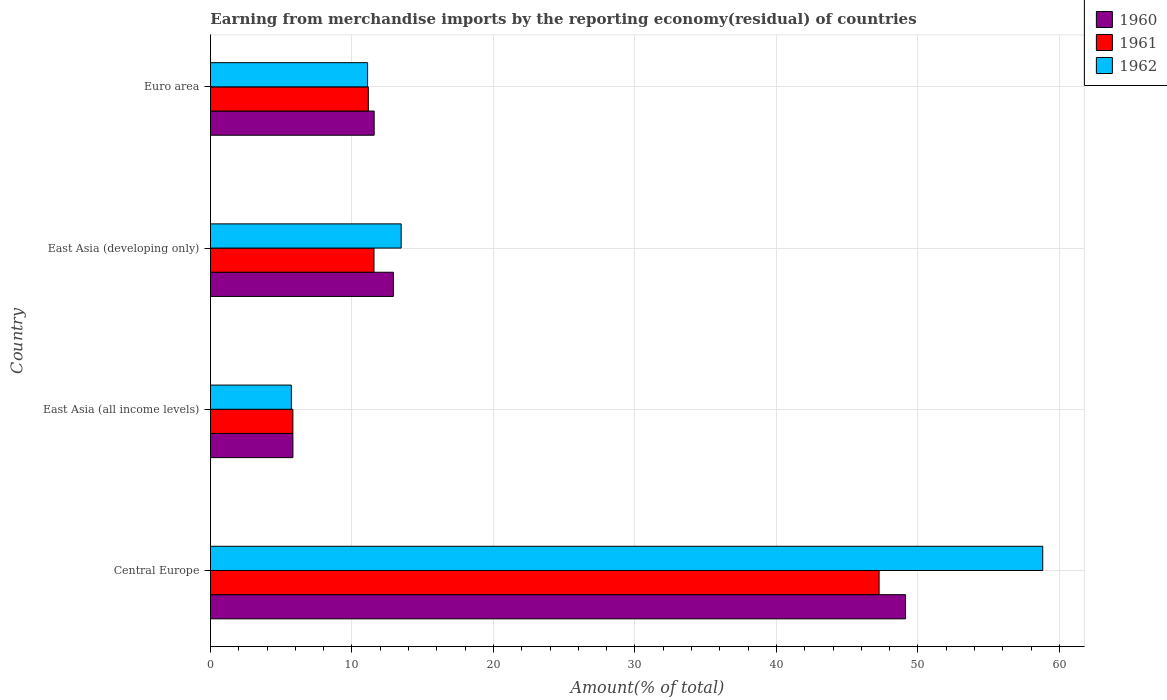How many different coloured bars are there?
Give a very brief answer. 3. How many bars are there on the 3rd tick from the top?
Offer a very short reply. 3. How many bars are there on the 2nd tick from the bottom?
Provide a short and direct response. 3. What is the label of the 1st group of bars from the top?
Your answer should be compact. Euro area. What is the percentage of amount earned from merchandise imports in 1961 in Central Europe?
Make the answer very short. 47.26. Across all countries, what is the maximum percentage of amount earned from merchandise imports in 1961?
Your response must be concise. 47.26. Across all countries, what is the minimum percentage of amount earned from merchandise imports in 1962?
Provide a short and direct response. 5.72. In which country was the percentage of amount earned from merchandise imports in 1962 maximum?
Your answer should be very brief. Central Europe. In which country was the percentage of amount earned from merchandise imports in 1960 minimum?
Your answer should be very brief. East Asia (all income levels). What is the total percentage of amount earned from merchandise imports in 1960 in the graph?
Offer a very short reply. 79.45. What is the difference between the percentage of amount earned from merchandise imports in 1962 in Central Europe and that in East Asia (all income levels)?
Give a very brief answer. 53.1. What is the difference between the percentage of amount earned from merchandise imports in 1962 in East Asia (all income levels) and the percentage of amount earned from merchandise imports in 1960 in Central Europe?
Ensure brevity in your answer.  -43.41. What is the average percentage of amount earned from merchandise imports in 1961 per country?
Make the answer very short. 18.95. What is the difference between the percentage of amount earned from merchandise imports in 1961 and percentage of amount earned from merchandise imports in 1960 in East Asia (developing only)?
Your response must be concise. -1.37. In how many countries, is the percentage of amount earned from merchandise imports in 1961 greater than 16 %?
Your answer should be very brief. 1. What is the ratio of the percentage of amount earned from merchandise imports in 1962 in East Asia (all income levels) to that in East Asia (developing only)?
Offer a terse response. 0.42. What is the difference between the highest and the second highest percentage of amount earned from merchandise imports in 1960?
Your answer should be compact. 36.2. What is the difference between the highest and the lowest percentage of amount earned from merchandise imports in 1960?
Give a very brief answer. 43.3. In how many countries, is the percentage of amount earned from merchandise imports in 1960 greater than the average percentage of amount earned from merchandise imports in 1960 taken over all countries?
Your response must be concise. 1. What does the 1st bar from the top in East Asia (developing only) represents?
Make the answer very short. 1962. What does the 3rd bar from the bottom in Euro area represents?
Your response must be concise. 1962. Is it the case that in every country, the sum of the percentage of amount earned from merchandise imports in 1960 and percentage of amount earned from merchandise imports in 1961 is greater than the percentage of amount earned from merchandise imports in 1962?
Offer a very short reply. Yes. How many countries are there in the graph?
Give a very brief answer. 4. What is the difference between two consecutive major ticks on the X-axis?
Provide a succinct answer. 10. Where does the legend appear in the graph?
Give a very brief answer. Top right. What is the title of the graph?
Give a very brief answer. Earning from merchandise imports by the reporting economy(residual) of countries. What is the label or title of the X-axis?
Provide a succinct answer. Amount(% of total). What is the Amount(% of total) in 1960 in Central Europe?
Your answer should be very brief. 49.12. What is the Amount(% of total) of 1961 in Central Europe?
Give a very brief answer. 47.26. What is the Amount(% of total) in 1962 in Central Europe?
Ensure brevity in your answer.  58.82. What is the Amount(% of total) in 1960 in East Asia (all income levels)?
Offer a terse response. 5.83. What is the Amount(% of total) of 1961 in East Asia (all income levels)?
Your answer should be very brief. 5.82. What is the Amount(% of total) in 1962 in East Asia (all income levels)?
Offer a very short reply. 5.72. What is the Amount(% of total) in 1960 in East Asia (developing only)?
Offer a very short reply. 12.93. What is the Amount(% of total) in 1961 in East Asia (developing only)?
Your response must be concise. 11.56. What is the Amount(% of total) in 1962 in East Asia (developing only)?
Give a very brief answer. 13.48. What is the Amount(% of total) of 1960 in Euro area?
Provide a succinct answer. 11.57. What is the Amount(% of total) of 1961 in Euro area?
Your answer should be very brief. 11.16. What is the Amount(% of total) of 1962 in Euro area?
Keep it short and to the point. 11.1. Across all countries, what is the maximum Amount(% of total) of 1960?
Give a very brief answer. 49.12. Across all countries, what is the maximum Amount(% of total) of 1961?
Keep it short and to the point. 47.26. Across all countries, what is the maximum Amount(% of total) of 1962?
Your answer should be compact. 58.82. Across all countries, what is the minimum Amount(% of total) in 1960?
Ensure brevity in your answer.  5.83. Across all countries, what is the minimum Amount(% of total) of 1961?
Offer a terse response. 5.82. Across all countries, what is the minimum Amount(% of total) in 1962?
Ensure brevity in your answer.  5.72. What is the total Amount(% of total) in 1960 in the graph?
Keep it short and to the point. 79.45. What is the total Amount(% of total) of 1961 in the graph?
Provide a short and direct response. 75.79. What is the total Amount(% of total) in 1962 in the graph?
Keep it short and to the point. 89.12. What is the difference between the Amount(% of total) of 1960 in Central Europe and that in East Asia (all income levels)?
Offer a very short reply. 43.3. What is the difference between the Amount(% of total) in 1961 in Central Europe and that in East Asia (all income levels)?
Provide a succinct answer. 41.43. What is the difference between the Amount(% of total) of 1962 in Central Europe and that in East Asia (all income levels)?
Make the answer very short. 53.1. What is the difference between the Amount(% of total) of 1960 in Central Europe and that in East Asia (developing only)?
Provide a short and direct response. 36.2. What is the difference between the Amount(% of total) in 1961 in Central Europe and that in East Asia (developing only)?
Your answer should be very brief. 35.7. What is the difference between the Amount(% of total) of 1962 in Central Europe and that in East Asia (developing only)?
Your answer should be compact. 45.34. What is the difference between the Amount(% of total) of 1960 in Central Europe and that in Euro area?
Keep it short and to the point. 37.56. What is the difference between the Amount(% of total) in 1961 in Central Europe and that in Euro area?
Provide a short and direct response. 36.1. What is the difference between the Amount(% of total) in 1962 in Central Europe and that in Euro area?
Provide a short and direct response. 47.72. What is the difference between the Amount(% of total) in 1960 in East Asia (all income levels) and that in East Asia (developing only)?
Your answer should be compact. -7.1. What is the difference between the Amount(% of total) of 1961 in East Asia (all income levels) and that in East Asia (developing only)?
Make the answer very short. -5.73. What is the difference between the Amount(% of total) of 1962 in East Asia (all income levels) and that in East Asia (developing only)?
Give a very brief answer. -7.76. What is the difference between the Amount(% of total) in 1960 in East Asia (all income levels) and that in Euro area?
Offer a very short reply. -5.74. What is the difference between the Amount(% of total) of 1961 in East Asia (all income levels) and that in Euro area?
Keep it short and to the point. -5.33. What is the difference between the Amount(% of total) in 1962 in East Asia (all income levels) and that in Euro area?
Your response must be concise. -5.39. What is the difference between the Amount(% of total) in 1960 in East Asia (developing only) and that in Euro area?
Provide a short and direct response. 1.36. What is the difference between the Amount(% of total) in 1961 in East Asia (developing only) and that in Euro area?
Your response must be concise. 0.4. What is the difference between the Amount(% of total) of 1962 in East Asia (developing only) and that in Euro area?
Your answer should be compact. 2.37. What is the difference between the Amount(% of total) in 1960 in Central Europe and the Amount(% of total) in 1961 in East Asia (all income levels)?
Provide a short and direct response. 43.3. What is the difference between the Amount(% of total) of 1960 in Central Europe and the Amount(% of total) of 1962 in East Asia (all income levels)?
Provide a short and direct response. 43.41. What is the difference between the Amount(% of total) in 1961 in Central Europe and the Amount(% of total) in 1962 in East Asia (all income levels)?
Your answer should be very brief. 41.54. What is the difference between the Amount(% of total) of 1960 in Central Europe and the Amount(% of total) of 1961 in East Asia (developing only)?
Offer a very short reply. 37.57. What is the difference between the Amount(% of total) of 1960 in Central Europe and the Amount(% of total) of 1962 in East Asia (developing only)?
Offer a very short reply. 35.65. What is the difference between the Amount(% of total) of 1961 in Central Europe and the Amount(% of total) of 1962 in East Asia (developing only)?
Your response must be concise. 33.78. What is the difference between the Amount(% of total) in 1960 in Central Europe and the Amount(% of total) in 1961 in Euro area?
Your answer should be very brief. 37.97. What is the difference between the Amount(% of total) in 1960 in Central Europe and the Amount(% of total) in 1962 in Euro area?
Ensure brevity in your answer.  38.02. What is the difference between the Amount(% of total) in 1961 in Central Europe and the Amount(% of total) in 1962 in Euro area?
Provide a short and direct response. 36.15. What is the difference between the Amount(% of total) in 1960 in East Asia (all income levels) and the Amount(% of total) in 1961 in East Asia (developing only)?
Provide a succinct answer. -5.73. What is the difference between the Amount(% of total) of 1960 in East Asia (all income levels) and the Amount(% of total) of 1962 in East Asia (developing only)?
Make the answer very short. -7.65. What is the difference between the Amount(% of total) in 1961 in East Asia (all income levels) and the Amount(% of total) in 1962 in East Asia (developing only)?
Make the answer very short. -7.65. What is the difference between the Amount(% of total) in 1960 in East Asia (all income levels) and the Amount(% of total) in 1961 in Euro area?
Your answer should be very brief. -5.33. What is the difference between the Amount(% of total) in 1960 in East Asia (all income levels) and the Amount(% of total) in 1962 in Euro area?
Make the answer very short. -5.28. What is the difference between the Amount(% of total) of 1961 in East Asia (all income levels) and the Amount(% of total) of 1962 in Euro area?
Make the answer very short. -5.28. What is the difference between the Amount(% of total) in 1960 in East Asia (developing only) and the Amount(% of total) in 1961 in Euro area?
Offer a terse response. 1.77. What is the difference between the Amount(% of total) of 1960 in East Asia (developing only) and the Amount(% of total) of 1962 in Euro area?
Offer a very short reply. 1.82. What is the difference between the Amount(% of total) of 1961 in East Asia (developing only) and the Amount(% of total) of 1962 in Euro area?
Provide a succinct answer. 0.45. What is the average Amount(% of total) in 1960 per country?
Your response must be concise. 19.86. What is the average Amount(% of total) in 1961 per country?
Keep it short and to the point. 18.95. What is the average Amount(% of total) of 1962 per country?
Ensure brevity in your answer.  22.28. What is the difference between the Amount(% of total) in 1960 and Amount(% of total) in 1961 in Central Europe?
Offer a very short reply. 1.87. What is the difference between the Amount(% of total) in 1960 and Amount(% of total) in 1962 in Central Europe?
Make the answer very short. -9.7. What is the difference between the Amount(% of total) of 1961 and Amount(% of total) of 1962 in Central Europe?
Ensure brevity in your answer.  -11.56. What is the difference between the Amount(% of total) in 1960 and Amount(% of total) in 1961 in East Asia (all income levels)?
Your response must be concise. 0. What is the difference between the Amount(% of total) in 1960 and Amount(% of total) in 1962 in East Asia (all income levels)?
Make the answer very short. 0.11. What is the difference between the Amount(% of total) in 1961 and Amount(% of total) in 1962 in East Asia (all income levels)?
Keep it short and to the point. 0.11. What is the difference between the Amount(% of total) of 1960 and Amount(% of total) of 1961 in East Asia (developing only)?
Provide a succinct answer. 1.37. What is the difference between the Amount(% of total) of 1960 and Amount(% of total) of 1962 in East Asia (developing only)?
Provide a short and direct response. -0.55. What is the difference between the Amount(% of total) in 1961 and Amount(% of total) in 1962 in East Asia (developing only)?
Provide a short and direct response. -1.92. What is the difference between the Amount(% of total) in 1960 and Amount(% of total) in 1961 in Euro area?
Ensure brevity in your answer.  0.41. What is the difference between the Amount(% of total) in 1960 and Amount(% of total) in 1962 in Euro area?
Your answer should be compact. 0.46. What is the difference between the Amount(% of total) in 1961 and Amount(% of total) in 1962 in Euro area?
Your answer should be very brief. 0.05. What is the ratio of the Amount(% of total) in 1960 in Central Europe to that in East Asia (all income levels)?
Ensure brevity in your answer.  8.43. What is the ratio of the Amount(% of total) of 1961 in Central Europe to that in East Asia (all income levels)?
Offer a very short reply. 8.12. What is the ratio of the Amount(% of total) in 1962 in Central Europe to that in East Asia (all income levels)?
Your answer should be very brief. 10.29. What is the ratio of the Amount(% of total) in 1960 in Central Europe to that in East Asia (developing only)?
Ensure brevity in your answer.  3.8. What is the ratio of the Amount(% of total) in 1961 in Central Europe to that in East Asia (developing only)?
Make the answer very short. 4.09. What is the ratio of the Amount(% of total) in 1962 in Central Europe to that in East Asia (developing only)?
Your answer should be very brief. 4.36. What is the ratio of the Amount(% of total) in 1960 in Central Europe to that in Euro area?
Keep it short and to the point. 4.25. What is the ratio of the Amount(% of total) of 1961 in Central Europe to that in Euro area?
Provide a succinct answer. 4.24. What is the ratio of the Amount(% of total) in 1962 in Central Europe to that in Euro area?
Your answer should be very brief. 5.3. What is the ratio of the Amount(% of total) of 1960 in East Asia (all income levels) to that in East Asia (developing only)?
Provide a short and direct response. 0.45. What is the ratio of the Amount(% of total) of 1961 in East Asia (all income levels) to that in East Asia (developing only)?
Keep it short and to the point. 0.5. What is the ratio of the Amount(% of total) in 1962 in East Asia (all income levels) to that in East Asia (developing only)?
Your response must be concise. 0.42. What is the ratio of the Amount(% of total) in 1960 in East Asia (all income levels) to that in Euro area?
Your answer should be very brief. 0.5. What is the ratio of the Amount(% of total) in 1961 in East Asia (all income levels) to that in Euro area?
Give a very brief answer. 0.52. What is the ratio of the Amount(% of total) in 1962 in East Asia (all income levels) to that in Euro area?
Offer a very short reply. 0.51. What is the ratio of the Amount(% of total) of 1960 in East Asia (developing only) to that in Euro area?
Make the answer very short. 1.12. What is the ratio of the Amount(% of total) of 1961 in East Asia (developing only) to that in Euro area?
Your answer should be very brief. 1.04. What is the ratio of the Amount(% of total) in 1962 in East Asia (developing only) to that in Euro area?
Keep it short and to the point. 1.21. What is the difference between the highest and the second highest Amount(% of total) in 1960?
Ensure brevity in your answer.  36.2. What is the difference between the highest and the second highest Amount(% of total) of 1961?
Your response must be concise. 35.7. What is the difference between the highest and the second highest Amount(% of total) of 1962?
Offer a terse response. 45.34. What is the difference between the highest and the lowest Amount(% of total) of 1960?
Make the answer very short. 43.3. What is the difference between the highest and the lowest Amount(% of total) of 1961?
Ensure brevity in your answer.  41.43. What is the difference between the highest and the lowest Amount(% of total) of 1962?
Provide a short and direct response. 53.1. 